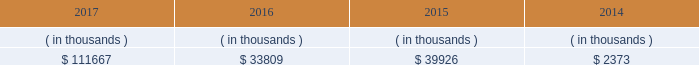System energy may refinance , redeem , or otherwise retire debt prior to maturity , to the extent market conditions and interest and dividend rates are favorable .
All debt and common stock issuances by system energy require prior regulatory approval . a0 a0debt issuances are also subject to issuance tests set forth in its bond indentures and other agreements . a0 a0system energy has sufficient capacity under these tests to meet its foreseeable capital needs .
System energy 2019s receivables from the money pool were as follows as of december 31 for each of the following years. .
See note 4 to the financial statements for a description of the money pool .
The system energy nuclear fuel company variable interest entity has a credit facility in the amount of $ 120 million scheduled to expire in may 2019 .
As of december 31 , 2017 , $ 17.8 million in letters of credit to support a like amount of commercial paper issued and $ 50 million in loans were outstanding under the system energy nuclear fuel company variable interest entity credit facility .
See note 4 to the financial statements for additional discussion of the variable interest entity credit facility .
System energy obtained authorizations from the ferc through october 2019 for the following : 2022 short-term borrowings not to exceed an aggregate amount of $ 200 million at any time outstanding ; 2022 long-term borrowings and security issuances ; and 2022 long-term borrowings by its nuclear fuel company variable interest entity .
See note 4 to the financial statements for further discussion of system energy 2019s short-term borrowing limits .
System energy resources , inc .
Management 2019s financial discussion and analysis federal regulation see the 201crate , cost-recovery , and other regulation 2013 federal regulation 201d section of entergy corporation and subsidiaries management 2019s financial discussion and analysis and note 2 to the financial statements for a discussion of federal regulation .
Complaint against system energy in january 2017 the apsc and mpsc filed a complaint with the ferc against system energy .
The complaint seeks a reduction in the return on equity component of the unit power sales agreement pursuant to which system energy sells its grand gulf capacity and energy to entergy arkansas , entergy louisiana , entergy mississippi , and entergy new orleans .
Entergy arkansas also sells some of its grand gulf capacity and energy to entergy louisiana , entergy mississippi , and entergy new orleans under separate agreements .
The current return on equity under the unit power sales agreement is 10.94% ( 10.94 % ) .
The complaint alleges that the return on equity is unjust and unreasonable because current capital market and other considerations indicate that it is excessive .
The complaint requests the ferc to institute proceedings to investigate the return on equity and establish a lower return on equity , and also requests that the ferc establish january 23 , 2017 as a refund effective date .
The complaint includes return on equity analysis that purports to establish that the range of reasonable return on equity for system energy is between 8.37% ( 8.37 % ) and 8.67% ( 8.67 % ) .
System energy answered the complaint in february 2017 and disputes that a return on equity of 8.37% ( 8.37 % ) to 8.67% ( 8.67 % ) is just and reasonable .
The lpsc and the city council intervened in the proceeding expressing support for the complaint .
System energy is recording a provision against revenue for the potential outcome of this proceeding .
In september 2017 the ferc established a refund effective date of january 23 , 2017 , consolidated the return on equity complaint with the proceeding described in unit power sales agreement below , and directed the parties to engage in settlement .
What percent did receivables from the money pool increase between 2014 and 2017? 
Computations: ((111667 - 2373) / 2373)
Answer: 46.05731. 